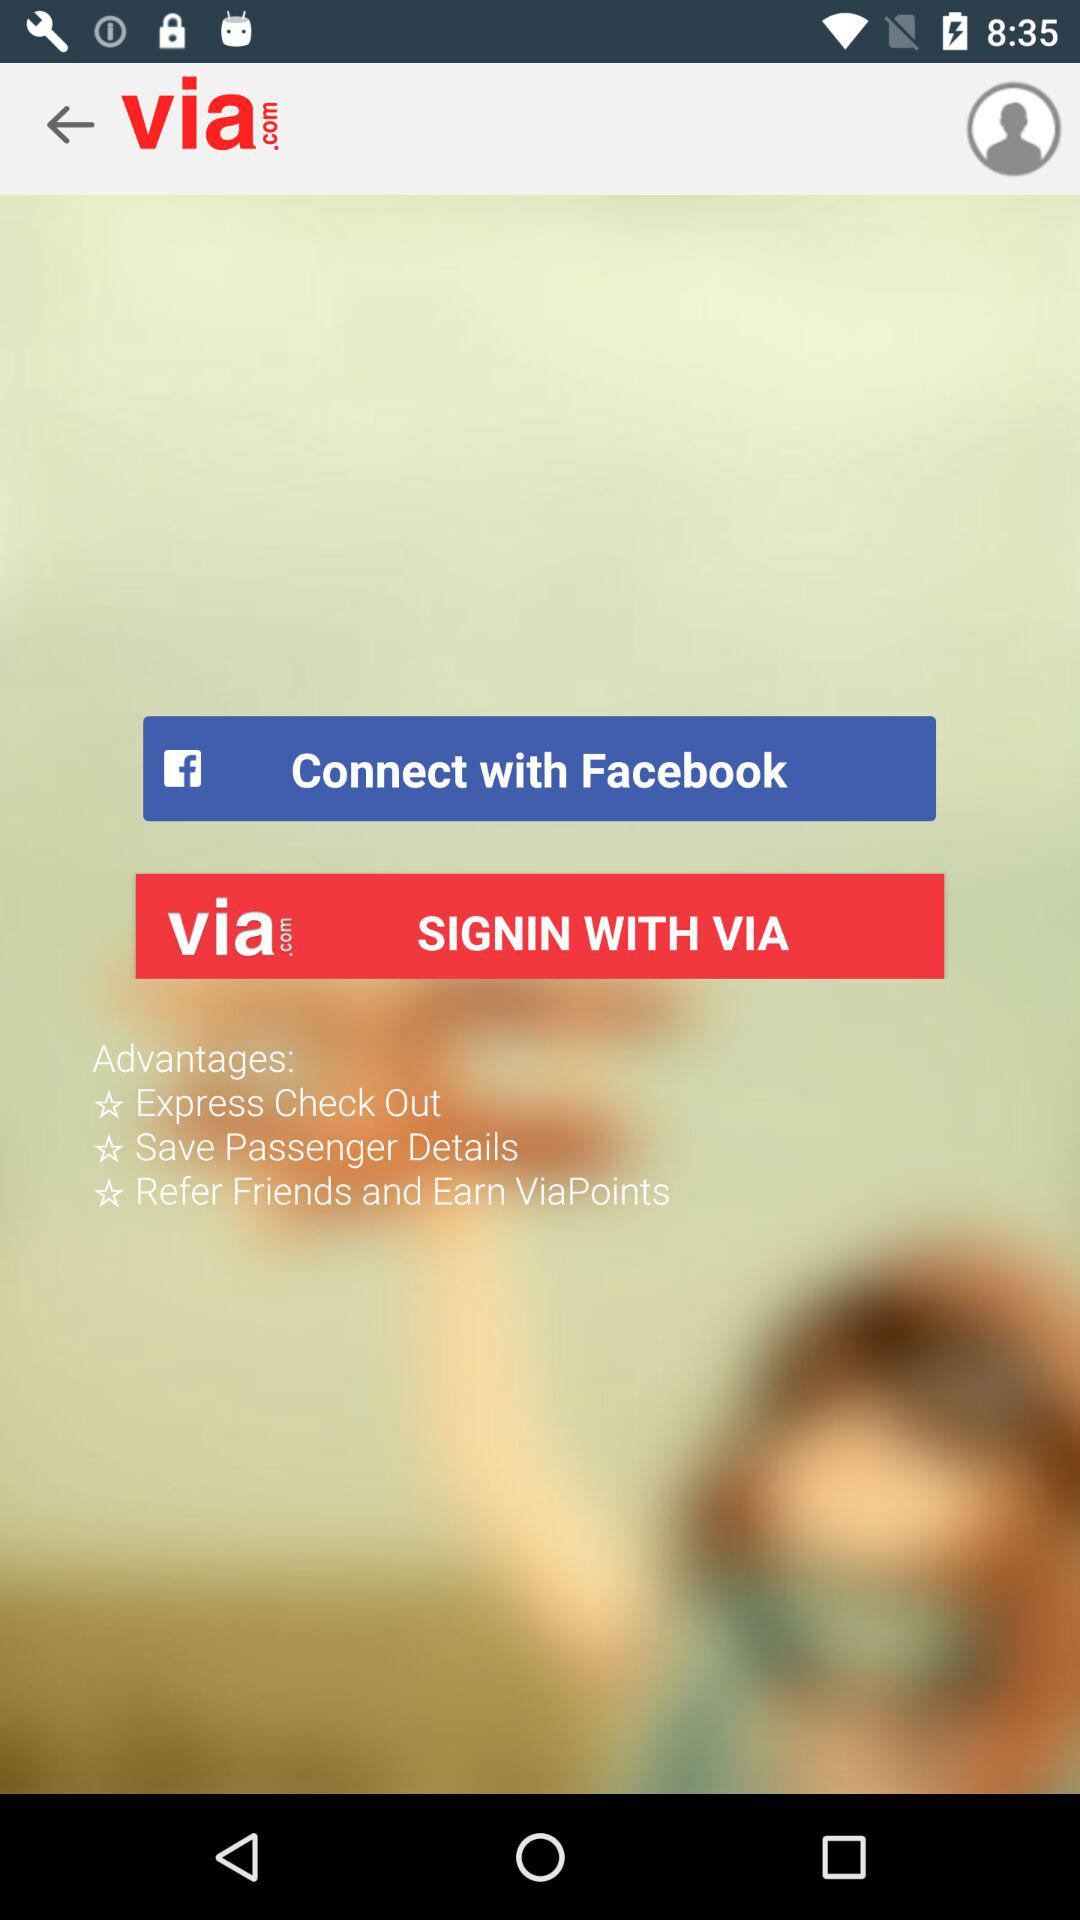What accounts can I use to sign in? You can sign in with "Facebook" and "VIA". 